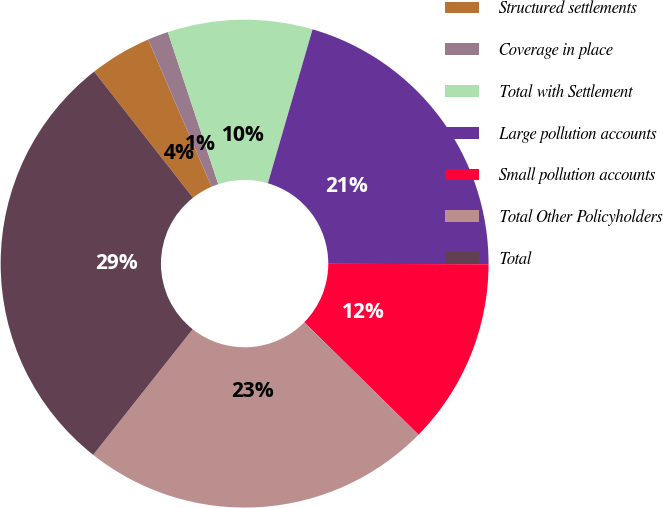Convert chart. <chart><loc_0><loc_0><loc_500><loc_500><pie_chart><fcel>Structured settlements<fcel>Coverage in place<fcel>Total with Settlement<fcel>Large pollution accounts<fcel>Small pollution accounts<fcel>Total Other Policyholders<fcel>Total<nl><fcel>4.11%<fcel>1.37%<fcel>9.59%<fcel>20.55%<fcel>12.33%<fcel>23.29%<fcel>28.77%<nl></chart> 